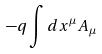Convert formula to latex. <formula><loc_0><loc_0><loc_500><loc_500>- q \int d x ^ { \mu } A _ { \mu }</formula> 